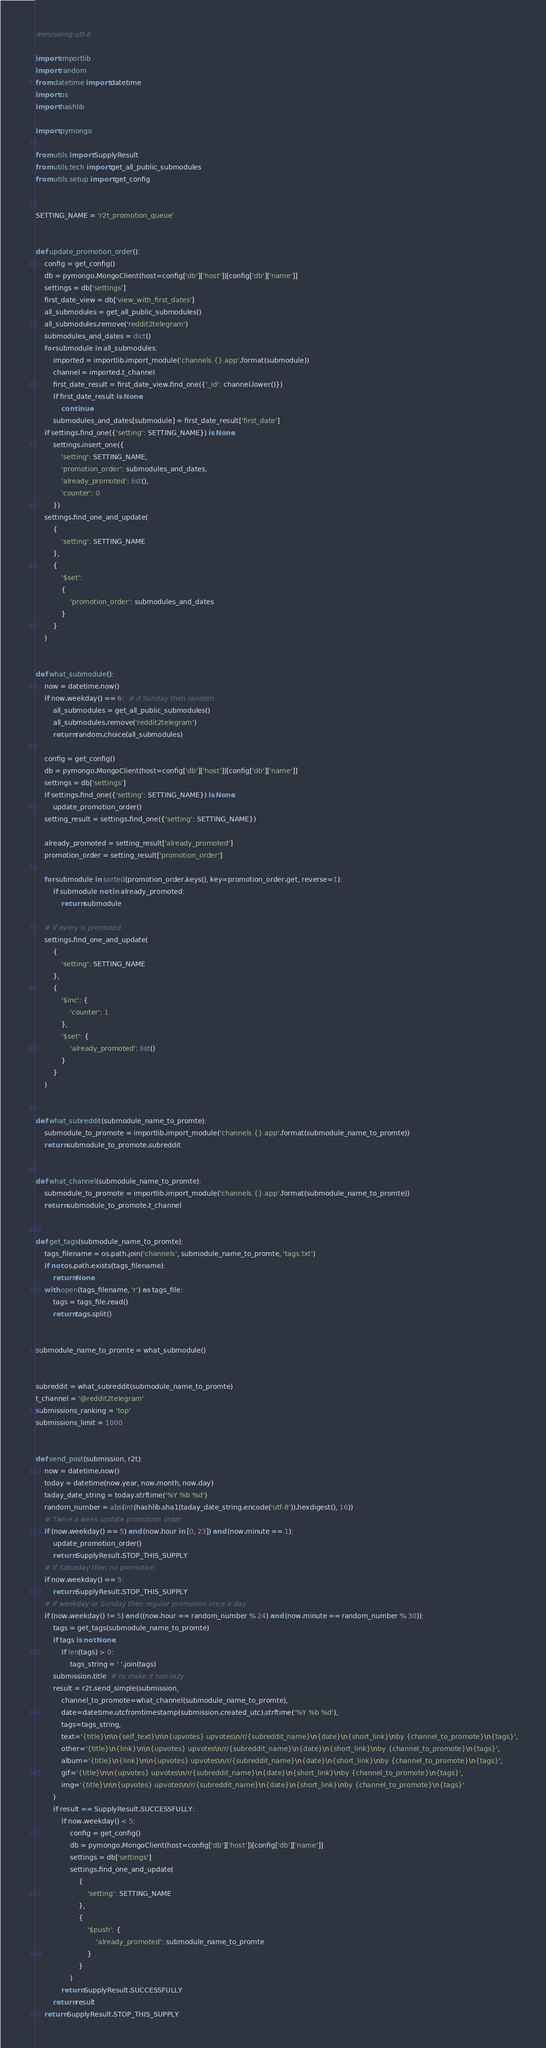<code> <loc_0><loc_0><loc_500><loc_500><_Python_>#encoding:utf-8

import importlib
import random
from datetime import datetime
import os
import hashlib

import pymongo

from utils import SupplyResult
from utils.tech import get_all_public_submodules
from utils.setup import get_config


SETTING_NAME = 'r2t_promotion_queue'


def update_promotion_order():
    config = get_config()
    db = pymongo.MongoClient(host=config['db']['host'])[config['db']['name']]
    settings = db['settings']
    first_date_view = db['view_with_first_dates']
    all_submodules = get_all_public_submodules()
    all_submodules.remove('reddit2telegram')
    submodules_and_dates = dict()
    for submodule in all_submodules:
        imported = importlib.import_module('channels.{}.app'.format(submodule))
        channel = imported.t_channel
        first_date_result = first_date_view.find_one({'_id': channel.lower()})
        if first_date_result is None:
            continue
        submodules_and_dates[submodule] = first_date_result['first_date']
    if settings.find_one({'setting': SETTING_NAME}) is None:
        settings.insert_one({
            'setting': SETTING_NAME,
            'promotion_order': submodules_and_dates,
            'already_promoted': list(),
            'counter': 0
        })
    settings.find_one_and_update(
        {
            'setting': SETTING_NAME
        },
        {
            '$set': 
            {
                'promotion_order': submodules_and_dates
            }
        }
    )


def what_submodule():
    now = datetime.now()
    if now.weekday() == 6:  # if Sunday then random
        all_submodules = get_all_public_submodules()
        all_submodules.remove('reddit2telegram')
        return random.choice(all_submodules)

    config = get_config()
    db = pymongo.MongoClient(host=config['db']['host'])[config['db']['name']]
    settings = db['settings']
    if settings.find_one({'setting': SETTING_NAME}) is None:
        update_promotion_order()
    setting_result = settings.find_one({'setting': SETTING_NAME})

    already_promoted = setting_result['already_promoted']
    promotion_order = setting_result['promotion_order']

    for submodule in sorted(promotion_order.keys(), key=promotion_order.get, reverse=1):
        if submodule not in already_promoted:
            return submodule

    # If every is promoted.
    settings.find_one_and_update(
        {
            'setting': SETTING_NAME
        },
        {
            '$inc': {
                'counter': 1
            },
            '$set': {
                'already_promoted': list()
            }
        }
    )


def what_subreddit(submodule_name_to_promte):
    submodule_to_promote = importlib.import_module('channels.{}.app'.format(submodule_name_to_promte))
    return submodule_to_promote.subreddit


def what_channel(submodule_name_to_promte):
    submodule_to_promote = importlib.import_module('channels.{}.app'.format(submodule_name_to_promte))
    return submodule_to_promote.t_channel


def get_tags(submodule_name_to_promte):
    tags_filename = os.path.join('channels', submodule_name_to_promte, 'tags.txt')
    if not os.path.exists(tags_filename):
        return None
    with open(tags_filename, 'r') as tags_file:
        tags = tags_file.read()
        return tags.split()


submodule_name_to_promte = what_submodule()


subreddit = what_subreddit(submodule_name_to_promte)
t_channel = '@reddit2telegram'
submissions_ranking = 'top'
submissions_limit = 1000


def send_post(submission, r2t):
    now = datetime.now()
    today = datetime(now.year, now.month, now.day)
    taday_date_string = today.strftime('%Y %b %d')
    random_number = abs(int(hashlib.sha1(taday_date_string.encode('utf-8')).hexdigest(), 16))
    # Twice a week update promotion order
    if (now.weekday() == 5) and (now.hour in [0, 23]) and (now.minute == 1):
        update_promotion_order()
        return SupplyResult.STOP_THIS_SUPPLY
    # If Saturday then no promotion
    if now.weekday() == 5:
        return SupplyResult.STOP_THIS_SUPPLY
    # If weekday or Sunday then regular promotion once a day
    if (now.weekday() != 5) and ((now.hour == random_number % 24) and (now.minute == random_number % 30)):
        tags = get_tags(submodule_name_to_promte)
        if tags is not None:
            if len(tags) > 0:
                tags_string = ' '.join(tags)
        submission.title  # to make it non-lazy
        result = r2t.send_simple(submission,
            channel_to_promote=what_channel(submodule_name_to_promte),
            date=datetime.utcfromtimestamp(submission.created_utc).strftime('%Y %b %d'),
            tags=tags_string,
            text='{title}\n\n{self_text}\n\n{upvotes} upvotes\n/r/{subreddit_name}\n{date}\n{short_link}\nby {channel_to_promote}\n{tags}',
            other='{title}\n{link}\n\n{upvotes} upvotes\n/r/{subreddit_name}\n{date}\n{short_link}\nby {channel_to_promote}\n{tags}',
            album='{title}\n{link}\n\n{upvotes} upvotes\n/r/{subreddit_name}\n{date}\n{short_link}\nby {channel_to_promote}\n{tags}',
            gif='{title}\n\n{upvotes} upvotes\n/r/{subreddit_name}\n{date}\n{short_link}\nby {channel_to_promote}\n{tags}',
            img='{title}\n\n{upvotes} upvotes\n/r/{subreddit_name}\n{date}\n{short_link}\nby {channel_to_promote}\n{tags}'
        )
        if result == SupplyResult.SUCCESSFULLY:
            if now.weekday() < 5:
                config = get_config()
                db = pymongo.MongoClient(host=config['db']['host'])[config['db']['name']]
                settings = db['settings']
                settings.find_one_and_update(
                    {
                        'setting': SETTING_NAME
                    },
                    {
                        '$push': {
                            'already_promoted': submodule_name_to_promte
                        }
                    }
                )
            return SupplyResult.SUCCESSFULLY
        return result
    return SupplyResult.STOP_THIS_SUPPLY
</code> 